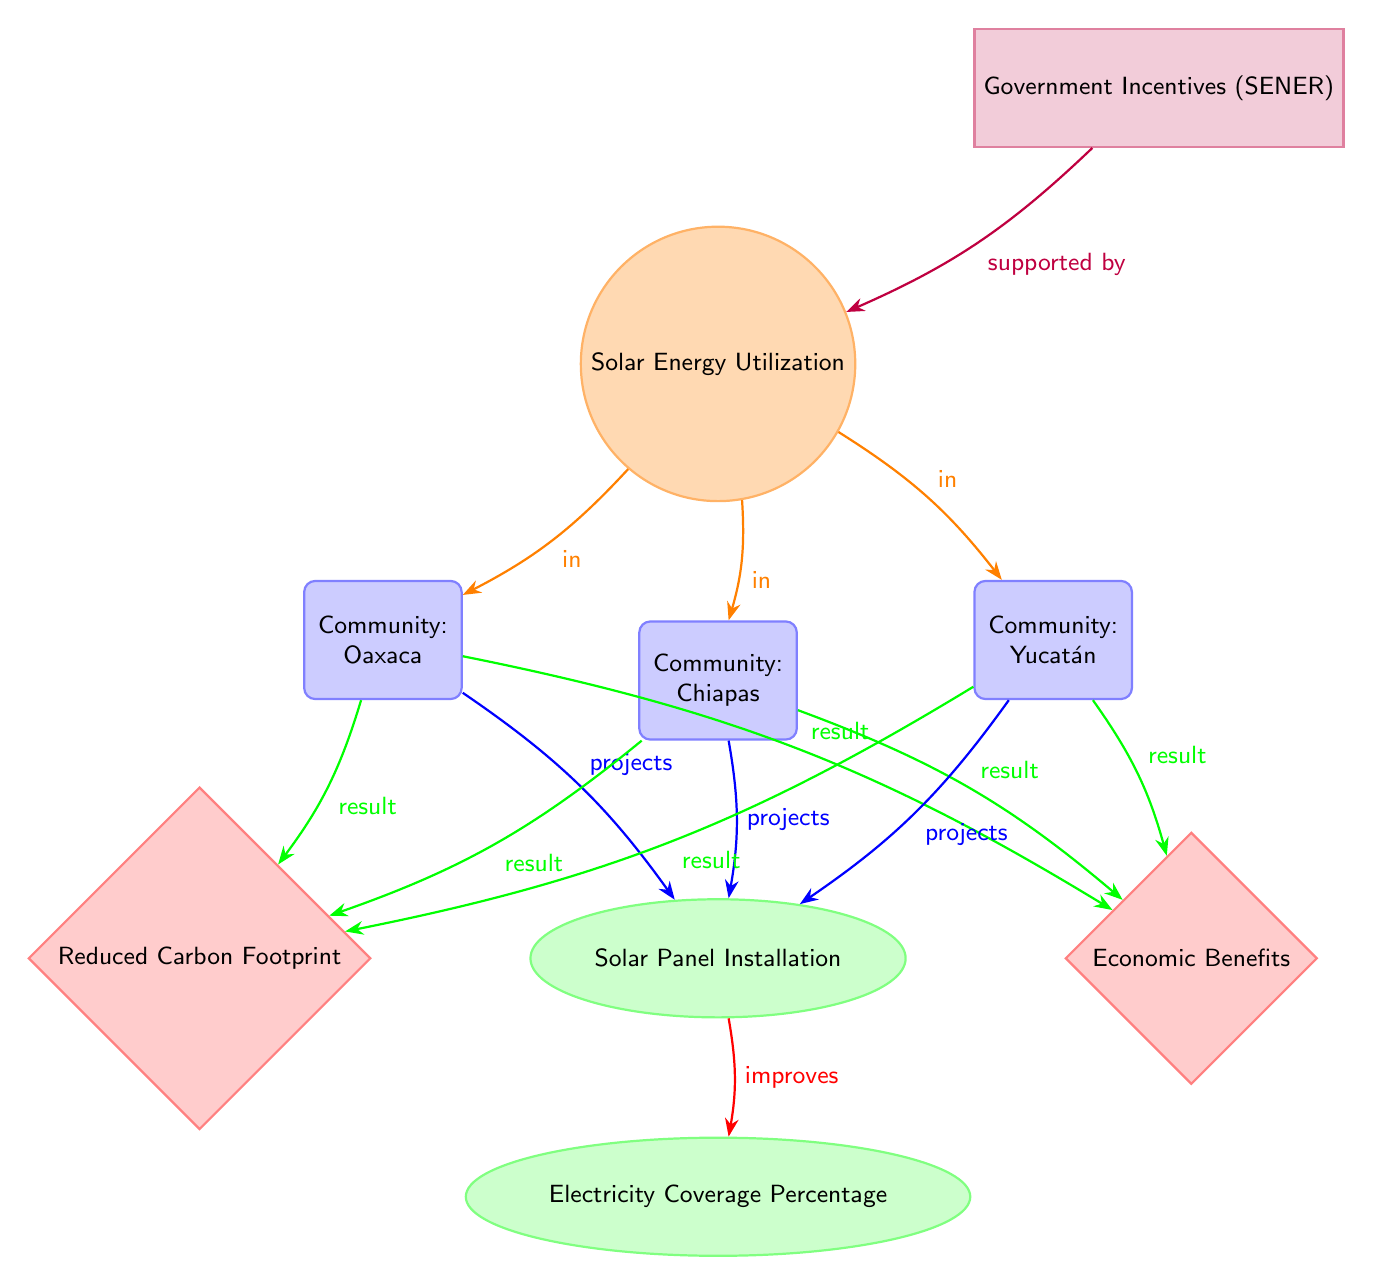What is the main subject of the diagram? The diagram centers around "Solar Energy Utilization," which is indicated as the main node at the top.
Answer: Solar Energy Utilization How many communities are represented in the diagram? The diagram includes three distinct communities: Oaxaca, Chiapas, and Yucatán, each represented as a node pointing towards the main subject.
Answer: Three Which community has a direct project link to solar panel installation? All three communities—Oaxaca, Chiapas, and Yucatán—are directly linked to the "Solar Panel Installation" effect as they each have an arrow leading to this node.
Answer: All What do the arrows between the communities and solar panel installation represent? The arrows signify the projects initiated in each community that lead to the effect of solar panel installation; thus, they represent implementation efforts.
Answer: Projects What are the two results of solar panel installation according to the diagram? The diagram indicates "Reduced Carbon Footprint" and "Economic Benefits" as the two results stemming from the solar panel installation effect.
Answer: Reduced Carbon Footprint, Economic Benefits How do government incentives relate to solar energy utilization? The diagram indicates that government incentives (SENER) are supportive of solar energy utilization, as shown by the arrow pointing from the incentives node to the main subject node.
Answer: Supported by What is the nature of the relationship between solar panel installation and electricity coverage percentage? The relationship is that solar panel installation improves electricity coverage percentage, as indicated by the arrow pointing from the solar panel installation effect to the electricity coverage percentage effect.
Answer: Improves Which effect does the community of Oaxaca connect to aside from solar panel installation? Oaxaca connects directly to both "Reduced Carbon Footprint" and "Economic Benefits," showing its benefits beyond just solar panel installation.
Answer: Reduced Carbon Footprint, Economic Benefits What shape is used to represent government incentives in the diagram? The diagram uses a rectangle shape to represent government incentives (SENER), which is noted in the color purple.
Answer: Rectangle 